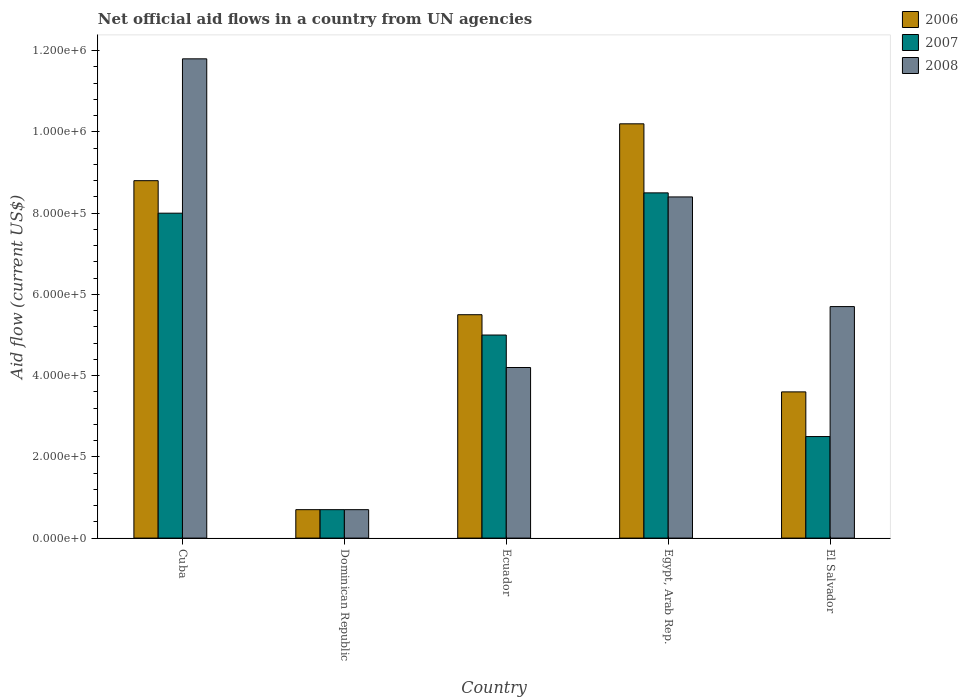How many groups of bars are there?
Offer a very short reply. 5. Are the number of bars on each tick of the X-axis equal?
Provide a succinct answer. Yes. What is the label of the 1st group of bars from the left?
Make the answer very short. Cuba. Across all countries, what is the maximum net official aid flow in 2008?
Give a very brief answer. 1.18e+06. Across all countries, what is the minimum net official aid flow in 2008?
Provide a short and direct response. 7.00e+04. In which country was the net official aid flow in 2006 maximum?
Your response must be concise. Egypt, Arab Rep. In which country was the net official aid flow in 2008 minimum?
Provide a short and direct response. Dominican Republic. What is the total net official aid flow in 2008 in the graph?
Your answer should be very brief. 3.08e+06. What is the difference between the net official aid flow in 2006 in Cuba and that in El Salvador?
Your answer should be very brief. 5.20e+05. What is the difference between the net official aid flow in 2007 in El Salvador and the net official aid flow in 2008 in Cuba?
Your answer should be compact. -9.30e+05. What is the average net official aid flow in 2006 per country?
Make the answer very short. 5.76e+05. What is the ratio of the net official aid flow in 2008 in Egypt, Arab Rep. to that in El Salvador?
Your answer should be compact. 1.47. Is the difference between the net official aid flow in 2008 in Dominican Republic and Ecuador greater than the difference between the net official aid flow in 2006 in Dominican Republic and Ecuador?
Keep it short and to the point. Yes. What is the difference between the highest and the second highest net official aid flow in 2008?
Provide a short and direct response. 3.40e+05. What is the difference between the highest and the lowest net official aid flow in 2007?
Provide a succinct answer. 7.80e+05. Are the values on the major ticks of Y-axis written in scientific E-notation?
Provide a succinct answer. Yes. Does the graph contain any zero values?
Your response must be concise. No. Does the graph contain grids?
Offer a terse response. No. Where does the legend appear in the graph?
Offer a very short reply. Top right. How many legend labels are there?
Provide a short and direct response. 3. What is the title of the graph?
Your answer should be compact. Net official aid flows in a country from UN agencies. What is the label or title of the X-axis?
Provide a succinct answer. Country. What is the label or title of the Y-axis?
Make the answer very short. Aid flow (current US$). What is the Aid flow (current US$) in 2006 in Cuba?
Make the answer very short. 8.80e+05. What is the Aid flow (current US$) of 2008 in Cuba?
Your answer should be very brief. 1.18e+06. What is the Aid flow (current US$) in 2007 in Ecuador?
Make the answer very short. 5.00e+05. What is the Aid flow (current US$) of 2006 in Egypt, Arab Rep.?
Offer a very short reply. 1.02e+06. What is the Aid flow (current US$) in 2007 in Egypt, Arab Rep.?
Provide a short and direct response. 8.50e+05. What is the Aid flow (current US$) of 2008 in Egypt, Arab Rep.?
Your response must be concise. 8.40e+05. What is the Aid flow (current US$) of 2006 in El Salvador?
Provide a succinct answer. 3.60e+05. What is the Aid flow (current US$) in 2008 in El Salvador?
Provide a short and direct response. 5.70e+05. Across all countries, what is the maximum Aid flow (current US$) of 2006?
Your answer should be very brief. 1.02e+06. Across all countries, what is the maximum Aid flow (current US$) of 2007?
Keep it short and to the point. 8.50e+05. Across all countries, what is the maximum Aid flow (current US$) of 2008?
Your answer should be very brief. 1.18e+06. Across all countries, what is the minimum Aid flow (current US$) of 2008?
Your answer should be compact. 7.00e+04. What is the total Aid flow (current US$) of 2006 in the graph?
Your response must be concise. 2.88e+06. What is the total Aid flow (current US$) of 2007 in the graph?
Your answer should be compact. 2.47e+06. What is the total Aid flow (current US$) of 2008 in the graph?
Make the answer very short. 3.08e+06. What is the difference between the Aid flow (current US$) in 2006 in Cuba and that in Dominican Republic?
Offer a terse response. 8.10e+05. What is the difference between the Aid flow (current US$) in 2007 in Cuba and that in Dominican Republic?
Offer a terse response. 7.30e+05. What is the difference between the Aid flow (current US$) in 2008 in Cuba and that in Dominican Republic?
Your answer should be compact. 1.11e+06. What is the difference between the Aid flow (current US$) of 2007 in Cuba and that in Ecuador?
Give a very brief answer. 3.00e+05. What is the difference between the Aid flow (current US$) in 2008 in Cuba and that in Ecuador?
Provide a short and direct response. 7.60e+05. What is the difference between the Aid flow (current US$) in 2007 in Cuba and that in Egypt, Arab Rep.?
Your response must be concise. -5.00e+04. What is the difference between the Aid flow (current US$) of 2006 in Cuba and that in El Salvador?
Your answer should be very brief. 5.20e+05. What is the difference between the Aid flow (current US$) in 2006 in Dominican Republic and that in Ecuador?
Make the answer very short. -4.80e+05. What is the difference between the Aid flow (current US$) of 2007 in Dominican Republic and that in Ecuador?
Your answer should be very brief. -4.30e+05. What is the difference between the Aid flow (current US$) in 2008 in Dominican Republic and that in Ecuador?
Ensure brevity in your answer.  -3.50e+05. What is the difference between the Aid flow (current US$) of 2006 in Dominican Republic and that in Egypt, Arab Rep.?
Your answer should be very brief. -9.50e+05. What is the difference between the Aid flow (current US$) in 2007 in Dominican Republic and that in Egypt, Arab Rep.?
Offer a very short reply. -7.80e+05. What is the difference between the Aid flow (current US$) of 2008 in Dominican Republic and that in Egypt, Arab Rep.?
Provide a short and direct response. -7.70e+05. What is the difference between the Aid flow (current US$) of 2007 in Dominican Republic and that in El Salvador?
Keep it short and to the point. -1.80e+05. What is the difference between the Aid flow (current US$) in 2008 in Dominican Republic and that in El Salvador?
Offer a terse response. -5.00e+05. What is the difference between the Aid flow (current US$) of 2006 in Ecuador and that in Egypt, Arab Rep.?
Make the answer very short. -4.70e+05. What is the difference between the Aid flow (current US$) in 2007 in Ecuador and that in Egypt, Arab Rep.?
Your answer should be compact. -3.50e+05. What is the difference between the Aid flow (current US$) of 2008 in Ecuador and that in Egypt, Arab Rep.?
Give a very brief answer. -4.20e+05. What is the difference between the Aid flow (current US$) in 2008 in Ecuador and that in El Salvador?
Your response must be concise. -1.50e+05. What is the difference between the Aid flow (current US$) in 2006 in Egypt, Arab Rep. and that in El Salvador?
Offer a very short reply. 6.60e+05. What is the difference between the Aid flow (current US$) of 2006 in Cuba and the Aid flow (current US$) of 2007 in Dominican Republic?
Make the answer very short. 8.10e+05. What is the difference between the Aid flow (current US$) of 2006 in Cuba and the Aid flow (current US$) of 2008 in Dominican Republic?
Offer a terse response. 8.10e+05. What is the difference between the Aid flow (current US$) of 2007 in Cuba and the Aid flow (current US$) of 2008 in Dominican Republic?
Your answer should be very brief. 7.30e+05. What is the difference between the Aid flow (current US$) in 2006 in Cuba and the Aid flow (current US$) in 2007 in Ecuador?
Provide a succinct answer. 3.80e+05. What is the difference between the Aid flow (current US$) in 2007 in Cuba and the Aid flow (current US$) in 2008 in Ecuador?
Make the answer very short. 3.80e+05. What is the difference between the Aid flow (current US$) of 2007 in Cuba and the Aid flow (current US$) of 2008 in Egypt, Arab Rep.?
Your answer should be very brief. -4.00e+04. What is the difference between the Aid flow (current US$) of 2006 in Cuba and the Aid flow (current US$) of 2007 in El Salvador?
Give a very brief answer. 6.30e+05. What is the difference between the Aid flow (current US$) in 2006 in Cuba and the Aid flow (current US$) in 2008 in El Salvador?
Offer a terse response. 3.10e+05. What is the difference between the Aid flow (current US$) in 2006 in Dominican Republic and the Aid flow (current US$) in 2007 in Ecuador?
Offer a terse response. -4.30e+05. What is the difference between the Aid flow (current US$) of 2006 in Dominican Republic and the Aid flow (current US$) of 2008 in Ecuador?
Offer a terse response. -3.50e+05. What is the difference between the Aid flow (current US$) of 2007 in Dominican Republic and the Aid flow (current US$) of 2008 in Ecuador?
Your response must be concise. -3.50e+05. What is the difference between the Aid flow (current US$) in 2006 in Dominican Republic and the Aid flow (current US$) in 2007 in Egypt, Arab Rep.?
Give a very brief answer. -7.80e+05. What is the difference between the Aid flow (current US$) in 2006 in Dominican Republic and the Aid flow (current US$) in 2008 in Egypt, Arab Rep.?
Your answer should be compact. -7.70e+05. What is the difference between the Aid flow (current US$) in 2007 in Dominican Republic and the Aid flow (current US$) in 2008 in Egypt, Arab Rep.?
Keep it short and to the point. -7.70e+05. What is the difference between the Aid flow (current US$) of 2006 in Dominican Republic and the Aid flow (current US$) of 2007 in El Salvador?
Offer a very short reply. -1.80e+05. What is the difference between the Aid flow (current US$) in 2006 in Dominican Republic and the Aid flow (current US$) in 2008 in El Salvador?
Your answer should be compact. -5.00e+05. What is the difference between the Aid flow (current US$) in 2007 in Dominican Republic and the Aid flow (current US$) in 2008 in El Salvador?
Your answer should be very brief. -5.00e+05. What is the difference between the Aid flow (current US$) of 2006 in Ecuador and the Aid flow (current US$) of 2008 in Egypt, Arab Rep.?
Make the answer very short. -2.90e+05. What is the difference between the Aid flow (current US$) in 2007 in Ecuador and the Aid flow (current US$) in 2008 in Egypt, Arab Rep.?
Provide a short and direct response. -3.40e+05. What is the difference between the Aid flow (current US$) in 2006 in Egypt, Arab Rep. and the Aid flow (current US$) in 2007 in El Salvador?
Keep it short and to the point. 7.70e+05. What is the difference between the Aid flow (current US$) of 2006 in Egypt, Arab Rep. and the Aid flow (current US$) of 2008 in El Salvador?
Your answer should be very brief. 4.50e+05. What is the difference between the Aid flow (current US$) of 2007 in Egypt, Arab Rep. and the Aid flow (current US$) of 2008 in El Salvador?
Make the answer very short. 2.80e+05. What is the average Aid flow (current US$) in 2006 per country?
Your answer should be compact. 5.76e+05. What is the average Aid flow (current US$) in 2007 per country?
Keep it short and to the point. 4.94e+05. What is the average Aid flow (current US$) in 2008 per country?
Ensure brevity in your answer.  6.16e+05. What is the difference between the Aid flow (current US$) of 2006 and Aid flow (current US$) of 2007 in Cuba?
Offer a terse response. 8.00e+04. What is the difference between the Aid flow (current US$) of 2006 and Aid flow (current US$) of 2008 in Cuba?
Offer a very short reply. -3.00e+05. What is the difference between the Aid flow (current US$) of 2007 and Aid flow (current US$) of 2008 in Cuba?
Your answer should be compact. -3.80e+05. What is the difference between the Aid flow (current US$) of 2006 and Aid flow (current US$) of 2007 in Dominican Republic?
Provide a short and direct response. 0. What is the difference between the Aid flow (current US$) of 2007 and Aid flow (current US$) of 2008 in Dominican Republic?
Give a very brief answer. 0. What is the difference between the Aid flow (current US$) of 2007 and Aid flow (current US$) of 2008 in Ecuador?
Provide a succinct answer. 8.00e+04. What is the difference between the Aid flow (current US$) in 2006 and Aid flow (current US$) in 2008 in Egypt, Arab Rep.?
Your response must be concise. 1.80e+05. What is the difference between the Aid flow (current US$) of 2007 and Aid flow (current US$) of 2008 in El Salvador?
Provide a short and direct response. -3.20e+05. What is the ratio of the Aid flow (current US$) of 2006 in Cuba to that in Dominican Republic?
Give a very brief answer. 12.57. What is the ratio of the Aid flow (current US$) of 2007 in Cuba to that in Dominican Republic?
Offer a terse response. 11.43. What is the ratio of the Aid flow (current US$) of 2008 in Cuba to that in Dominican Republic?
Offer a terse response. 16.86. What is the ratio of the Aid flow (current US$) in 2008 in Cuba to that in Ecuador?
Keep it short and to the point. 2.81. What is the ratio of the Aid flow (current US$) in 2006 in Cuba to that in Egypt, Arab Rep.?
Your response must be concise. 0.86. What is the ratio of the Aid flow (current US$) in 2008 in Cuba to that in Egypt, Arab Rep.?
Ensure brevity in your answer.  1.4. What is the ratio of the Aid flow (current US$) of 2006 in Cuba to that in El Salvador?
Your response must be concise. 2.44. What is the ratio of the Aid flow (current US$) of 2007 in Cuba to that in El Salvador?
Your answer should be very brief. 3.2. What is the ratio of the Aid flow (current US$) of 2008 in Cuba to that in El Salvador?
Your response must be concise. 2.07. What is the ratio of the Aid flow (current US$) in 2006 in Dominican Republic to that in Ecuador?
Keep it short and to the point. 0.13. What is the ratio of the Aid flow (current US$) of 2007 in Dominican Republic to that in Ecuador?
Provide a succinct answer. 0.14. What is the ratio of the Aid flow (current US$) in 2006 in Dominican Republic to that in Egypt, Arab Rep.?
Offer a very short reply. 0.07. What is the ratio of the Aid flow (current US$) of 2007 in Dominican Republic to that in Egypt, Arab Rep.?
Offer a very short reply. 0.08. What is the ratio of the Aid flow (current US$) in 2008 in Dominican Republic to that in Egypt, Arab Rep.?
Ensure brevity in your answer.  0.08. What is the ratio of the Aid flow (current US$) of 2006 in Dominican Republic to that in El Salvador?
Make the answer very short. 0.19. What is the ratio of the Aid flow (current US$) in 2007 in Dominican Republic to that in El Salvador?
Your answer should be compact. 0.28. What is the ratio of the Aid flow (current US$) of 2008 in Dominican Republic to that in El Salvador?
Provide a short and direct response. 0.12. What is the ratio of the Aid flow (current US$) of 2006 in Ecuador to that in Egypt, Arab Rep.?
Your answer should be very brief. 0.54. What is the ratio of the Aid flow (current US$) of 2007 in Ecuador to that in Egypt, Arab Rep.?
Offer a terse response. 0.59. What is the ratio of the Aid flow (current US$) in 2008 in Ecuador to that in Egypt, Arab Rep.?
Keep it short and to the point. 0.5. What is the ratio of the Aid flow (current US$) of 2006 in Ecuador to that in El Salvador?
Your answer should be compact. 1.53. What is the ratio of the Aid flow (current US$) of 2007 in Ecuador to that in El Salvador?
Offer a terse response. 2. What is the ratio of the Aid flow (current US$) of 2008 in Ecuador to that in El Salvador?
Offer a very short reply. 0.74. What is the ratio of the Aid flow (current US$) of 2006 in Egypt, Arab Rep. to that in El Salvador?
Your answer should be compact. 2.83. What is the ratio of the Aid flow (current US$) of 2007 in Egypt, Arab Rep. to that in El Salvador?
Your answer should be compact. 3.4. What is the ratio of the Aid flow (current US$) in 2008 in Egypt, Arab Rep. to that in El Salvador?
Offer a very short reply. 1.47. What is the difference between the highest and the second highest Aid flow (current US$) of 2008?
Offer a very short reply. 3.40e+05. What is the difference between the highest and the lowest Aid flow (current US$) of 2006?
Give a very brief answer. 9.50e+05. What is the difference between the highest and the lowest Aid flow (current US$) of 2007?
Your answer should be compact. 7.80e+05. What is the difference between the highest and the lowest Aid flow (current US$) of 2008?
Provide a short and direct response. 1.11e+06. 